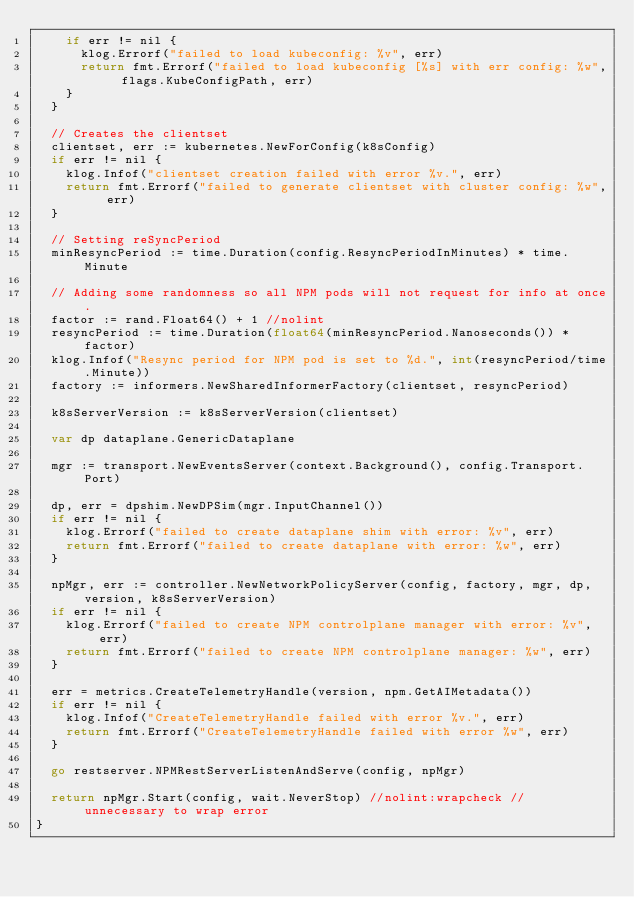Convert code to text. <code><loc_0><loc_0><loc_500><loc_500><_Go_>		if err != nil {
			klog.Errorf("failed to load kubeconfig: %v", err)
			return fmt.Errorf("failed to load kubeconfig [%s] with err config: %w", flags.KubeConfigPath, err)
		}
	}

	// Creates the clientset
	clientset, err := kubernetes.NewForConfig(k8sConfig)
	if err != nil {
		klog.Infof("clientset creation failed with error %v.", err)
		return fmt.Errorf("failed to generate clientset with cluster config: %w", err)
	}

	// Setting reSyncPeriod
	minResyncPeriod := time.Duration(config.ResyncPeriodInMinutes) * time.Minute

	// Adding some randomness so all NPM pods will not request for info at once.
	factor := rand.Float64() + 1 //nolint
	resyncPeriod := time.Duration(float64(minResyncPeriod.Nanoseconds()) * factor)
	klog.Infof("Resync period for NPM pod is set to %d.", int(resyncPeriod/time.Minute))
	factory := informers.NewSharedInformerFactory(clientset, resyncPeriod)

	k8sServerVersion := k8sServerVersion(clientset)

	var dp dataplane.GenericDataplane

	mgr := transport.NewEventsServer(context.Background(), config.Transport.Port)

	dp, err = dpshim.NewDPSim(mgr.InputChannel())
	if err != nil {
		klog.Errorf("failed to create dataplane shim with error: %v", err)
		return fmt.Errorf("failed to create dataplane with error: %w", err)
	}

	npMgr, err := controller.NewNetworkPolicyServer(config, factory, mgr, dp, version, k8sServerVersion)
	if err != nil {
		klog.Errorf("failed to create NPM controlplane manager with error: %v", err)
		return fmt.Errorf("failed to create NPM controlplane manager: %w", err)
	}

	err = metrics.CreateTelemetryHandle(version, npm.GetAIMetadata())
	if err != nil {
		klog.Infof("CreateTelemetryHandle failed with error %v.", err)
		return fmt.Errorf("CreateTelemetryHandle failed with error %w", err)
	}

	go restserver.NPMRestServerListenAndServe(config, npMgr)

	return npMgr.Start(config, wait.NeverStop) //nolint:wrapcheck // unnecessary to wrap error
}
</code> 